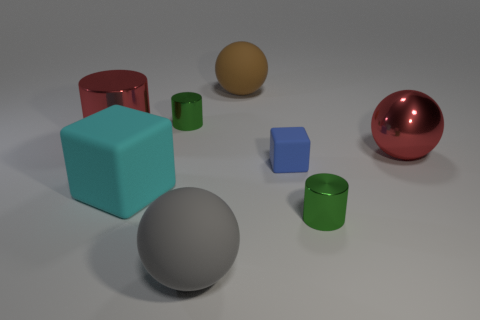Subtract all red blocks. How many green cylinders are left? 2 Subtract all brown spheres. How many spheres are left? 2 Add 1 blue cubes. How many objects exist? 9 Subtract all cylinders. How many objects are left? 5 Subtract all cyan spheres. Subtract all red cubes. How many spheres are left? 3 Subtract 0 brown cylinders. How many objects are left? 8 Subtract all tiny cylinders. Subtract all large cyan matte objects. How many objects are left? 5 Add 1 green metal cylinders. How many green metal cylinders are left? 3 Add 7 small cylinders. How many small cylinders exist? 9 